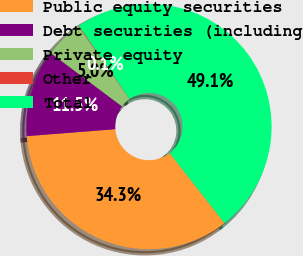Convert chart. <chart><loc_0><loc_0><loc_500><loc_500><pie_chart><fcel>Public equity securities<fcel>Debt securities (including<fcel>Private equity<fcel>Other<fcel>Total<nl><fcel>34.32%<fcel>11.49%<fcel>5.0%<fcel>0.1%<fcel>49.1%<nl></chart> 